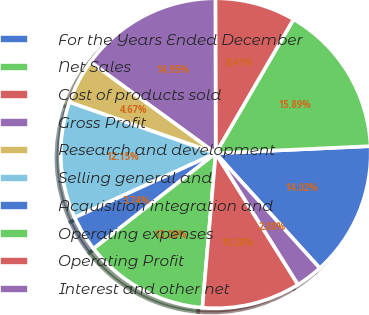Convert chart to OTSL. <chart><loc_0><loc_0><loc_500><loc_500><pie_chart><fcel>For the Years Ended December<fcel>Net Sales<fcel>Cost of products sold<fcel>Gross Profit<fcel>Research and development<fcel>Selling general and<fcel>Acquisition integration and<fcel>Operating expenses<fcel>Operating Profit<fcel>Interest and other net<nl><fcel>14.02%<fcel>15.89%<fcel>8.41%<fcel>14.95%<fcel>4.67%<fcel>12.15%<fcel>3.74%<fcel>13.08%<fcel>10.28%<fcel>2.8%<nl></chart> 